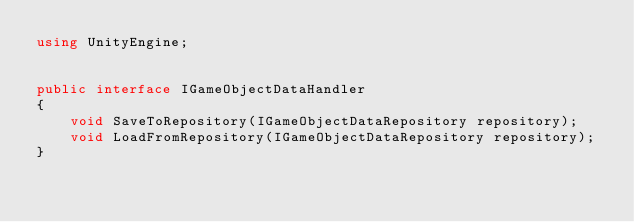<code> <loc_0><loc_0><loc_500><loc_500><_C#_>using UnityEngine;
 

public interface IGameObjectDataHandler
{
	void SaveToRepository(IGameObjectDataRepository repository);
	void LoadFromRepository(IGameObjectDataRepository repository);
}

</code> 